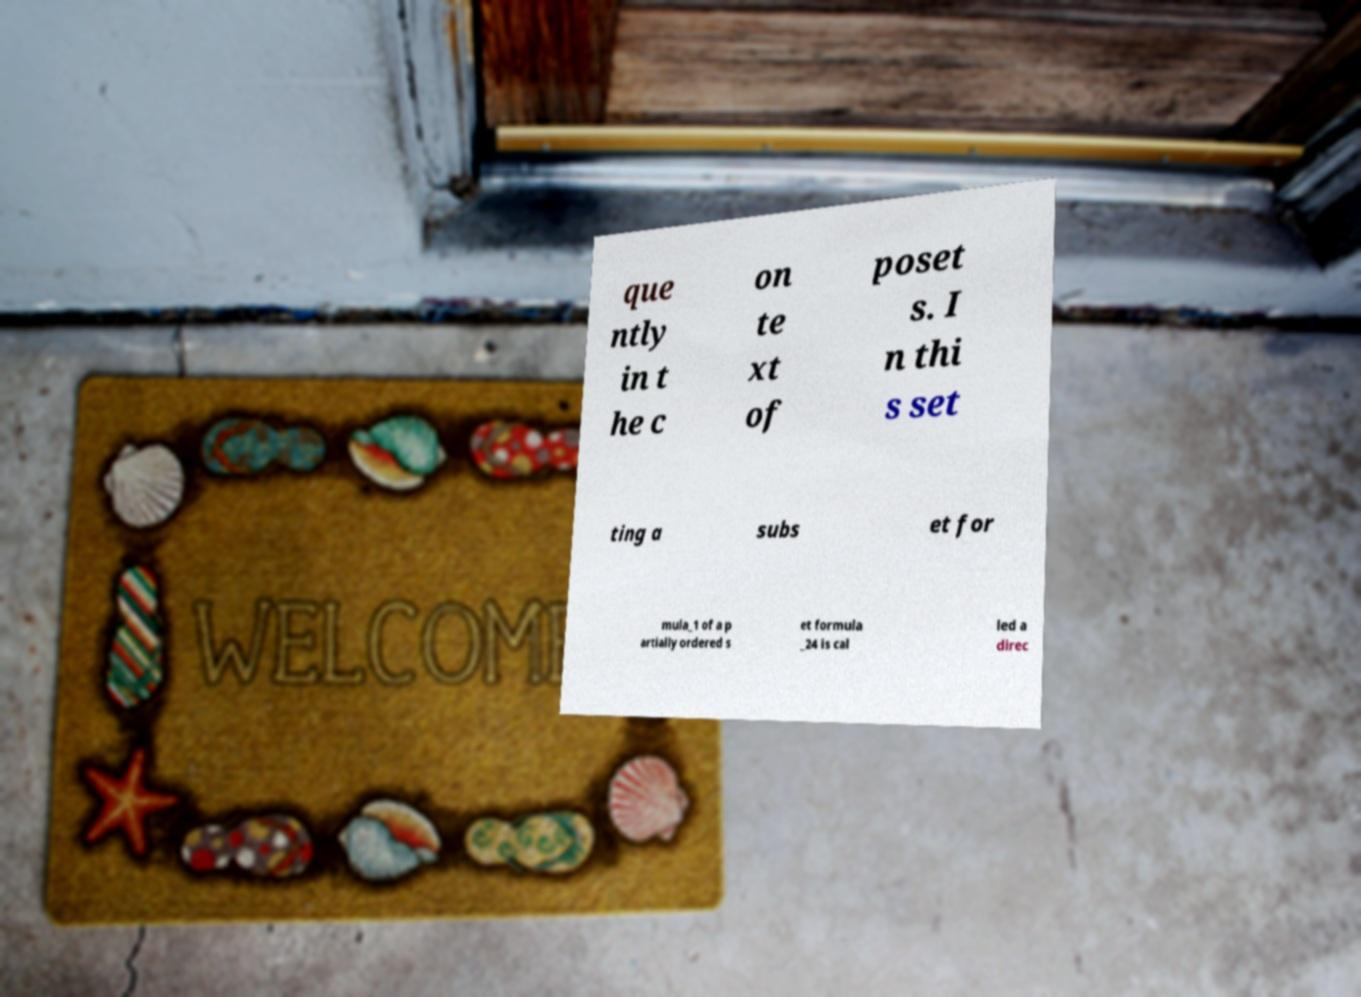Can you read and provide the text displayed in the image?This photo seems to have some interesting text. Can you extract and type it out for me? que ntly in t he c on te xt of poset s. I n thi s set ting a subs et for mula_1 of a p artially ordered s et formula _24 is cal led a direc 